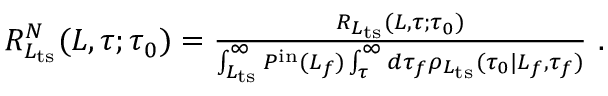Convert formula to latex. <formula><loc_0><loc_0><loc_500><loc_500>\begin{array} { r } { R _ { L _ { t s } } ^ { N } ( L , \tau ; \tau _ { 0 } ) = \frac { R _ { L _ { t s } } ( L , \tau ; \tau _ { 0 } ) } { \int _ { L _ { t s } } ^ { \infty } P ^ { i n } ( L _ { f } ) \int _ { \tau } ^ { \infty } d \tau _ { f } \rho _ { L _ { t s } } ( \tau _ { 0 } | L _ { f } , \tau _ { f } ) } \ . } \end{array}</formula> 